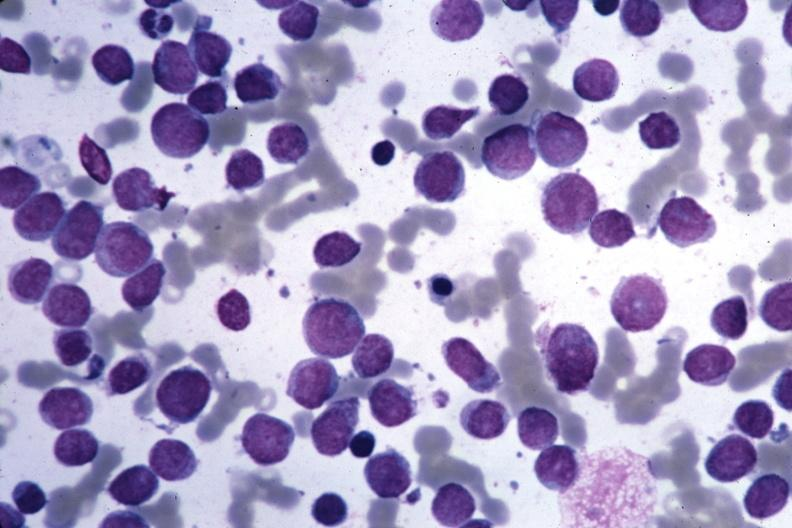s siamese twins present?
Answer the question using a single word or phrase. No 